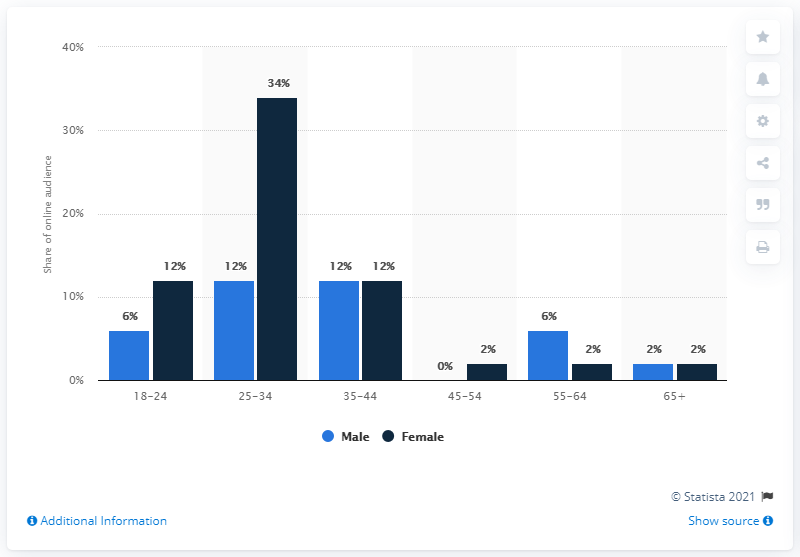Why might there be such a disparity between genders in the 25-34 age group? The visible gender disparity in the 25-34 age group may stem from a combination of social, cultural, or economic factors that influence the interests or behavior of different genders in this particular dataset. It could reflect targeted marketing efforts, variations in tech industry employment, or other demographic trends specific to this group.  Are there industry or cultural trends that could be inferred from this data? Yes, the data may suggest industry trends such as greater male participation in certain sectors often popular among the 25-34 age range. Culturally, it could indicate prevailing gender norms or the impact of policies on work-life balance. It's essential to note that to draw definitive conclusions, more context beyond this data is needed. 